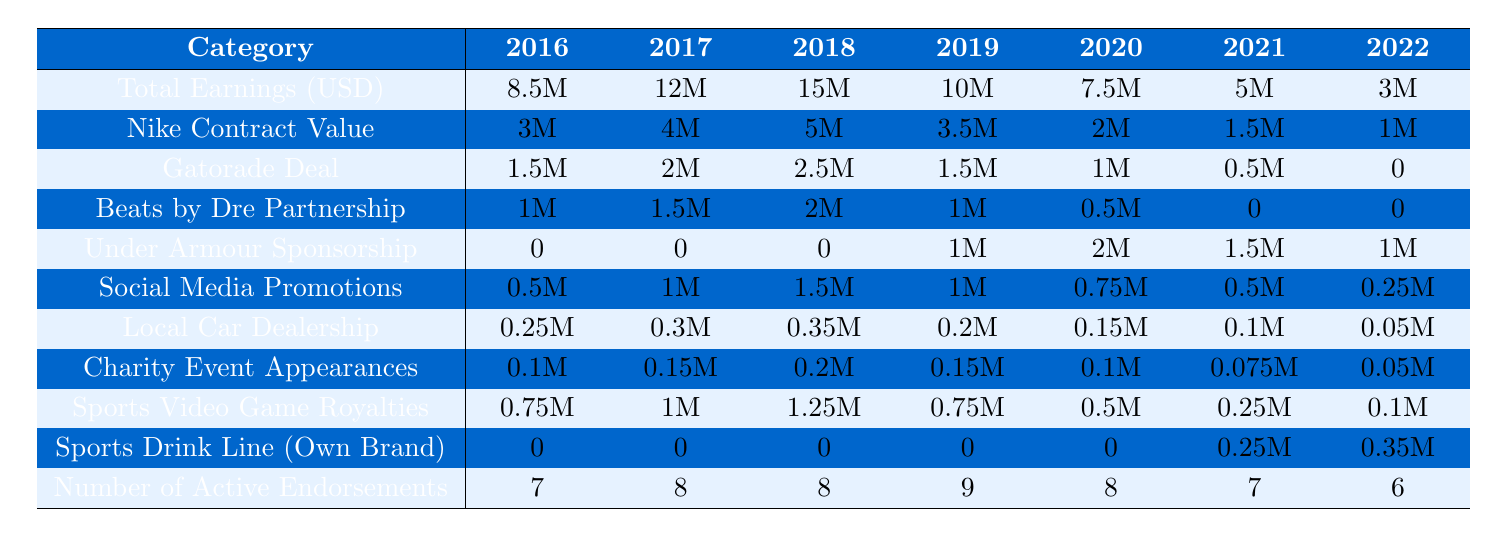What was Josh Peters' highest total earnings in a year? Looking at the "Total Earnings (USD)" row, the highest value is 15 million in 2018.
Answer: 15 million Which year saw the least earnings from the Gatorade deal? By observing the "Gatorade Deal" row, the lowest value is 0 in 2022.
Answer: 2022 In which year did Josh have the highest number of active endorsements? The row "Number of Active Endorsements" shows that 2019 had the highest value of 9 endorsements.
Answer: 2019 What was the total earnings decrease from 2018 to 2022? Total earnings in 2018 were 15 million and in 2022 were 3 million. The decrease is 15 million - 3 million = 12 million.
Answer: 12 million Was there any year where the earnings from Beats by Dre Partnership were zero? Checking the "Beats by Dre Partnership" row, it shows zeros in both 2021 and 2022.
Answer: Yes What was the trend in Nike Contract Value from 2016 to 2022? The values decreased from 3 million to 1 million over the years, indicating a downward trend.
Answer: Downward trend Which type of endorsement had the most significant earning in 2021? Reviewing each category, the "Under Armour Sponsorship" earned the most at 1.5 million in 2021.
Answer: Under Armour Sponsorship Calculating the average yearly earnings over the years from 2016 to 2022, what is the result? Summing the total earnings: 8.5 + 12 + 15 + 10 + 7.5 + 5 + 3 = 61 million; then dividing by 7 gives 61/7 ≈ 8.71 million.
Answer: Approximately 8.71 million In which year did Josh Peters earn the least from social media promotions? The "Social Media Promotions" row shows the lowest value of 0.25 million in 2022.
Answer: 2022 What was the total earnings from the Sports Drink Line from 2021 to 2022? The earnings for the Sports Drink Line were 0.25 million in 2021 and 0.35 million in 2022. Adding these gives 0.25 million + 0.35 million = 0.6 million.
Answer: 0.6 million 